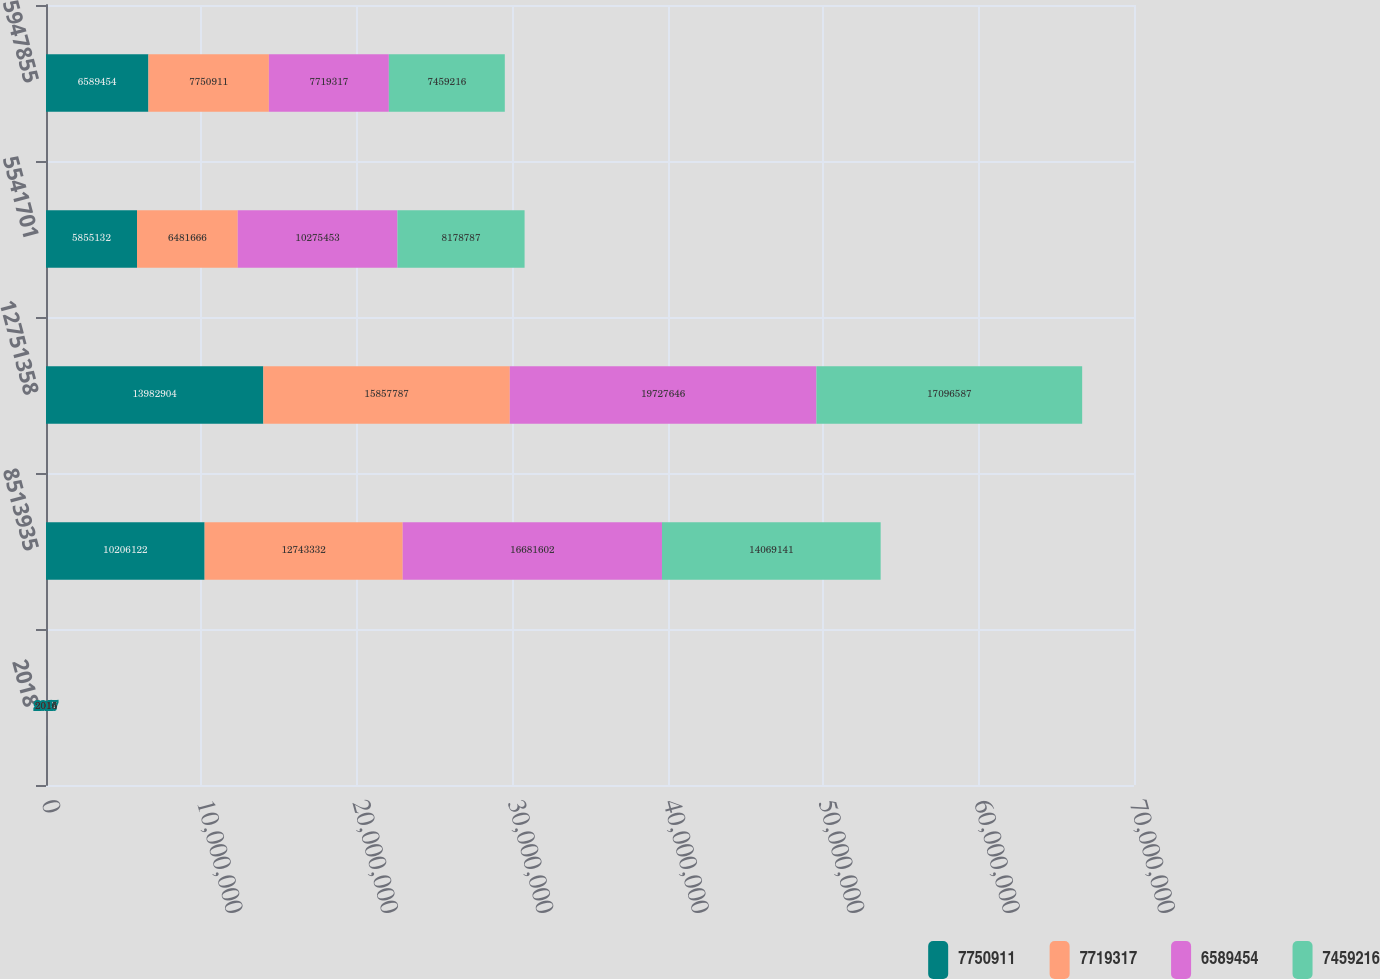Convert chart. <chart><loc_0><loc_0><loc_500><loc_500><stacked_bar_chart><ecel><fcel>2018<fcel>8513935<fcel>12751358<fcel>5541701<fcel>5947855<nl><fcel>7.75091e+06<fcel>2017<fcel>1.02061e+07<fcel>1.39829e+07<fcel>5.85513e+06<fcel>6.58945e+06<nl><fcel>7.71932e+06<fcel>2016<fcel>1.27433e+07<fcel>1.58578e+07<fcel>6.48167e+06<fcel>7.75091e+06<nl><fcel>6.58945e+06<fcel>2015<fcel>1.66816e+07<fcel>1.97276e+07<fcel>1.02755e+07<fcel>7.71932e+06<nl><fcel>7.45922e+06<fcel>2014<fcel>1.40691e+07<fcel>1.70966e+07<fcel>8.17879e+06<fcel>7.45922e+06<nl></chart> 